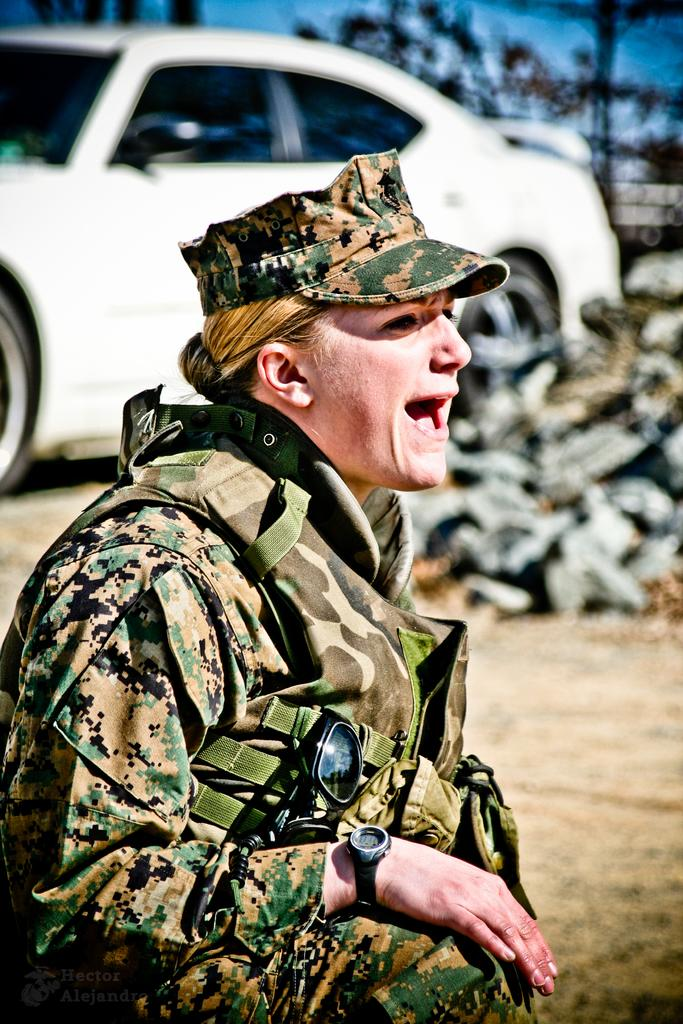What is the person in the image doing? The person is sitting on the ground in the image. What can be seen in the background of the image? There are motor vehicles and trees in the background of the image. What is visible in the sky in the image? The sky is visible in the background of the image. What type of pickle is the person holding in the image? There is no pickle present in the image; the person is sitting on the ground without any visible objects in their hands. 